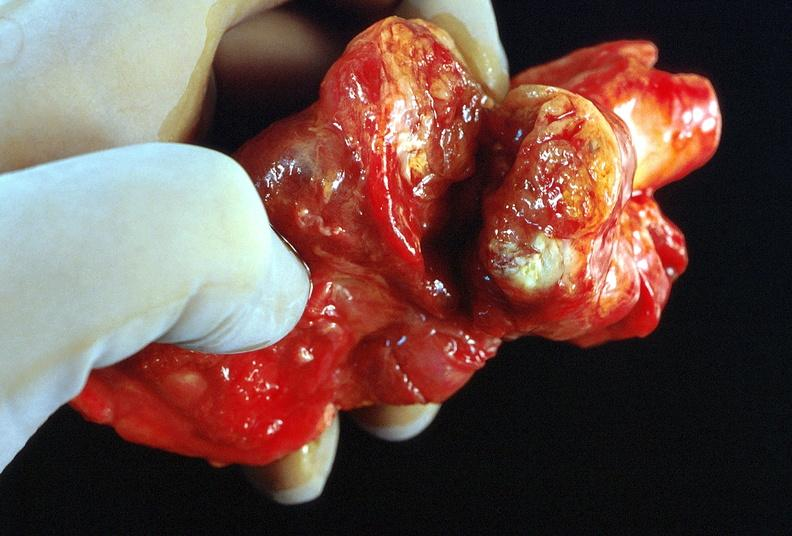what does this image show?
Answer the question using a single word or phrase. Thyroid 